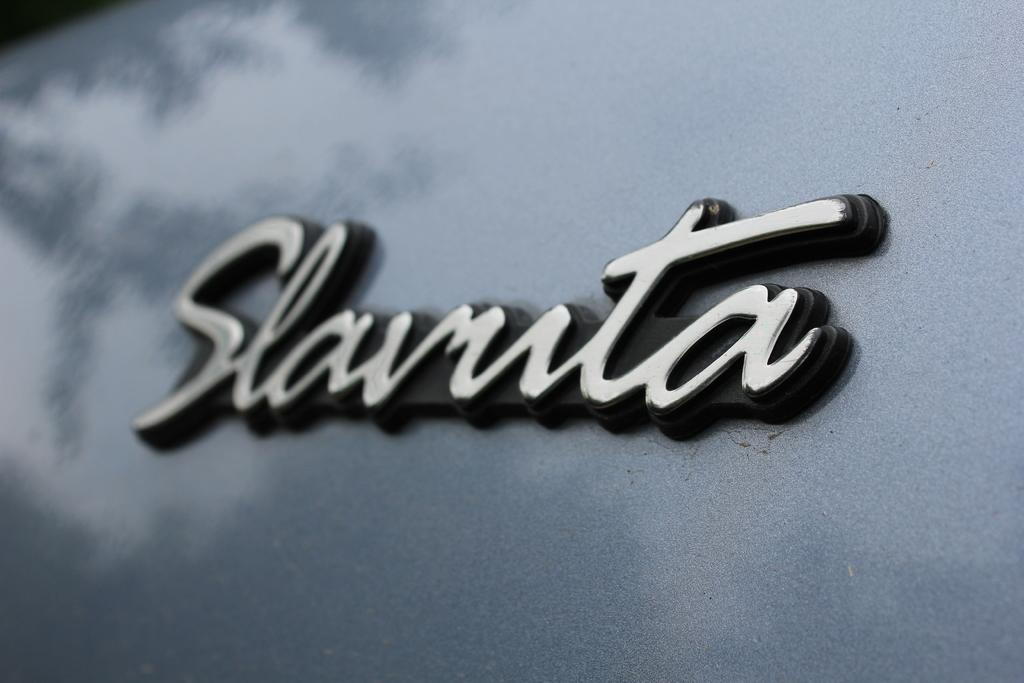What is the primary color of the surface in the image? The primary color of the surface in the image is grey. What is written or depicted on the grey surface? There is text on the grey surface. Where is the orange drain located in the image? There is no orange drain present in the image. 